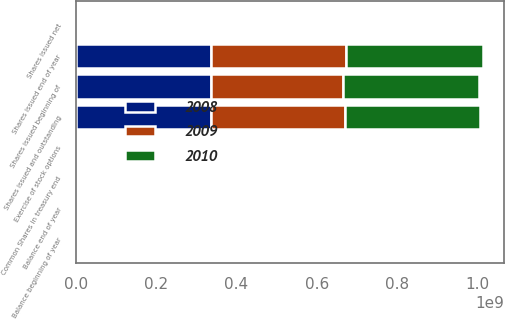Convert chart. <chart><loc_0><loc_0><loc_500><loc_500><stacked_bar_chart><ecel><fcel>Shares issued beginning of<fcel>Shares issued net<fcel>Exercise of stock options<fcel>Shares issued end of year<fcel>Common Shares in treasury end<fcel>Shares issued and outstanding<fcel>Balance beginning of year<fcel>Balance end of year<nl><fcel>2010<fcel>3.37842e+08<fcel>2.268e+06<fcel>984943<fcel>3.41095e+08<fcel>6.15171e+06<fcel>3.34943e+08<fcel>101481<fcel>101481<nl><fcel>2008<fcel>3.35414e+08<fcel>2e+06<fcel>168720<fcel>3.37842e+08<fcel>1.31696e+06<fcel>3.36525e+08<fcel>108981<fcel>101481<nl><fcel>2009<fcel>3.29705e+08<fcel>3.14019e+06<fcel>2.3654e+06<fcel>3.35414e+08<fcel>1.76803e+06<fcel>3.33645e+08<fcel>117231<fcel>108981<nl></chart> 